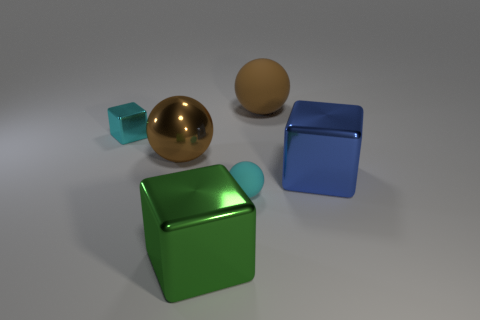If we were to arrange these objects by weight, lightest to heaviest, what would that order be, assuming they're all made of the same material? Based on their sizes and assuming they are made of the same material, the arrangement from lightest to heaviest would likely be: the small turquoise piece, the brown sphere, the blue cube, the gold sphere, and finally the green cube as the heaviest. 